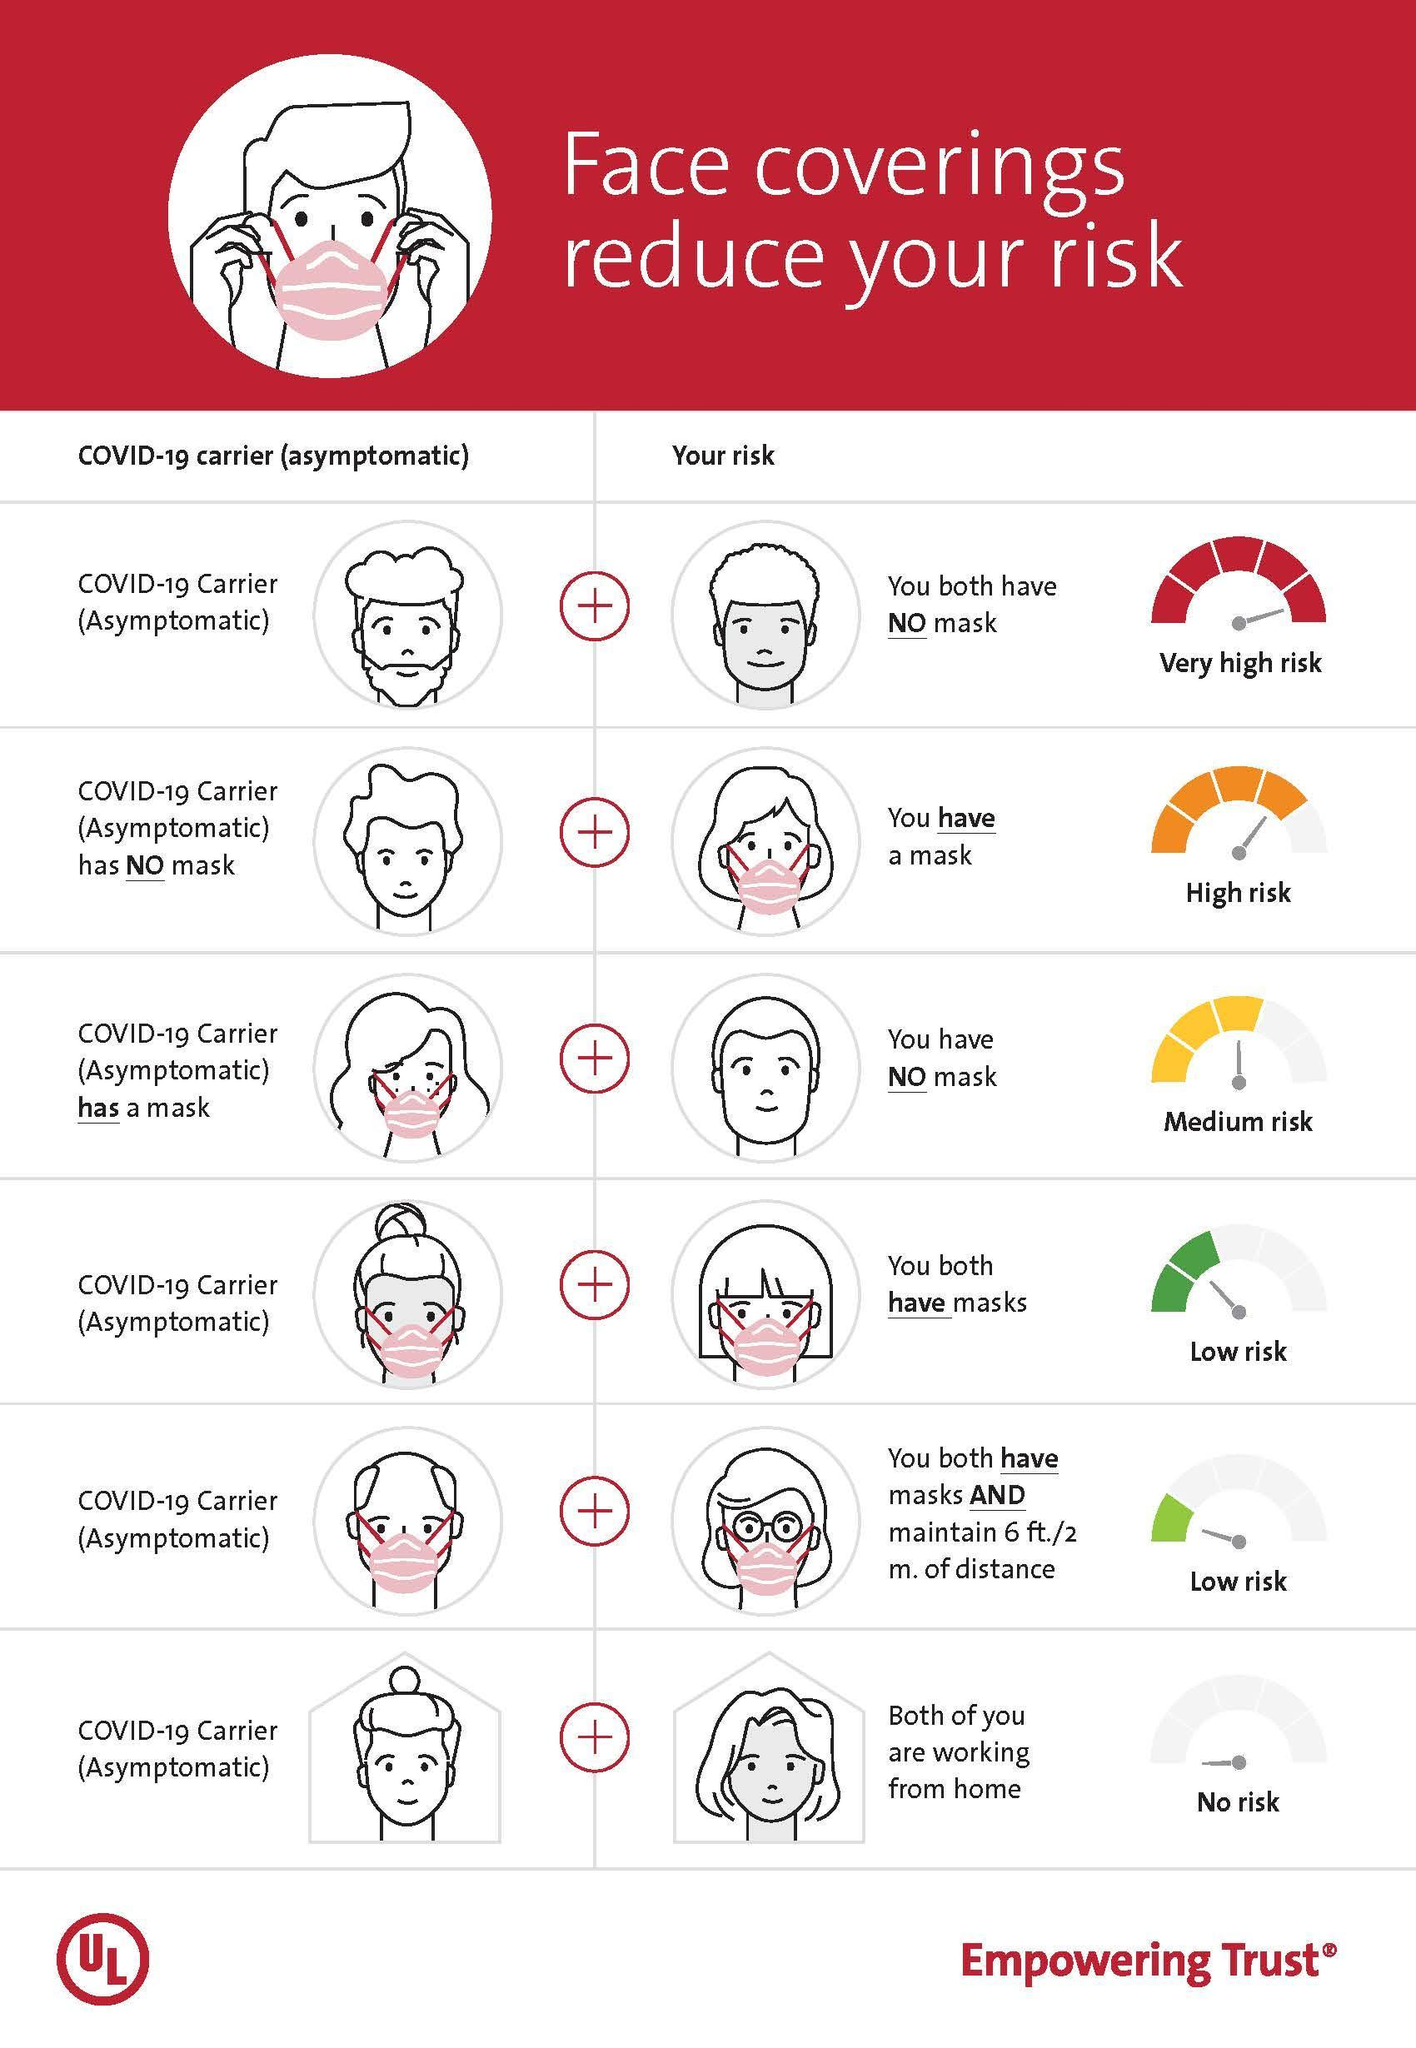How many people are with a mask in this infographic?
Answer the question with a short phrase. 7 How many people are without a mask in this infographic? 6 